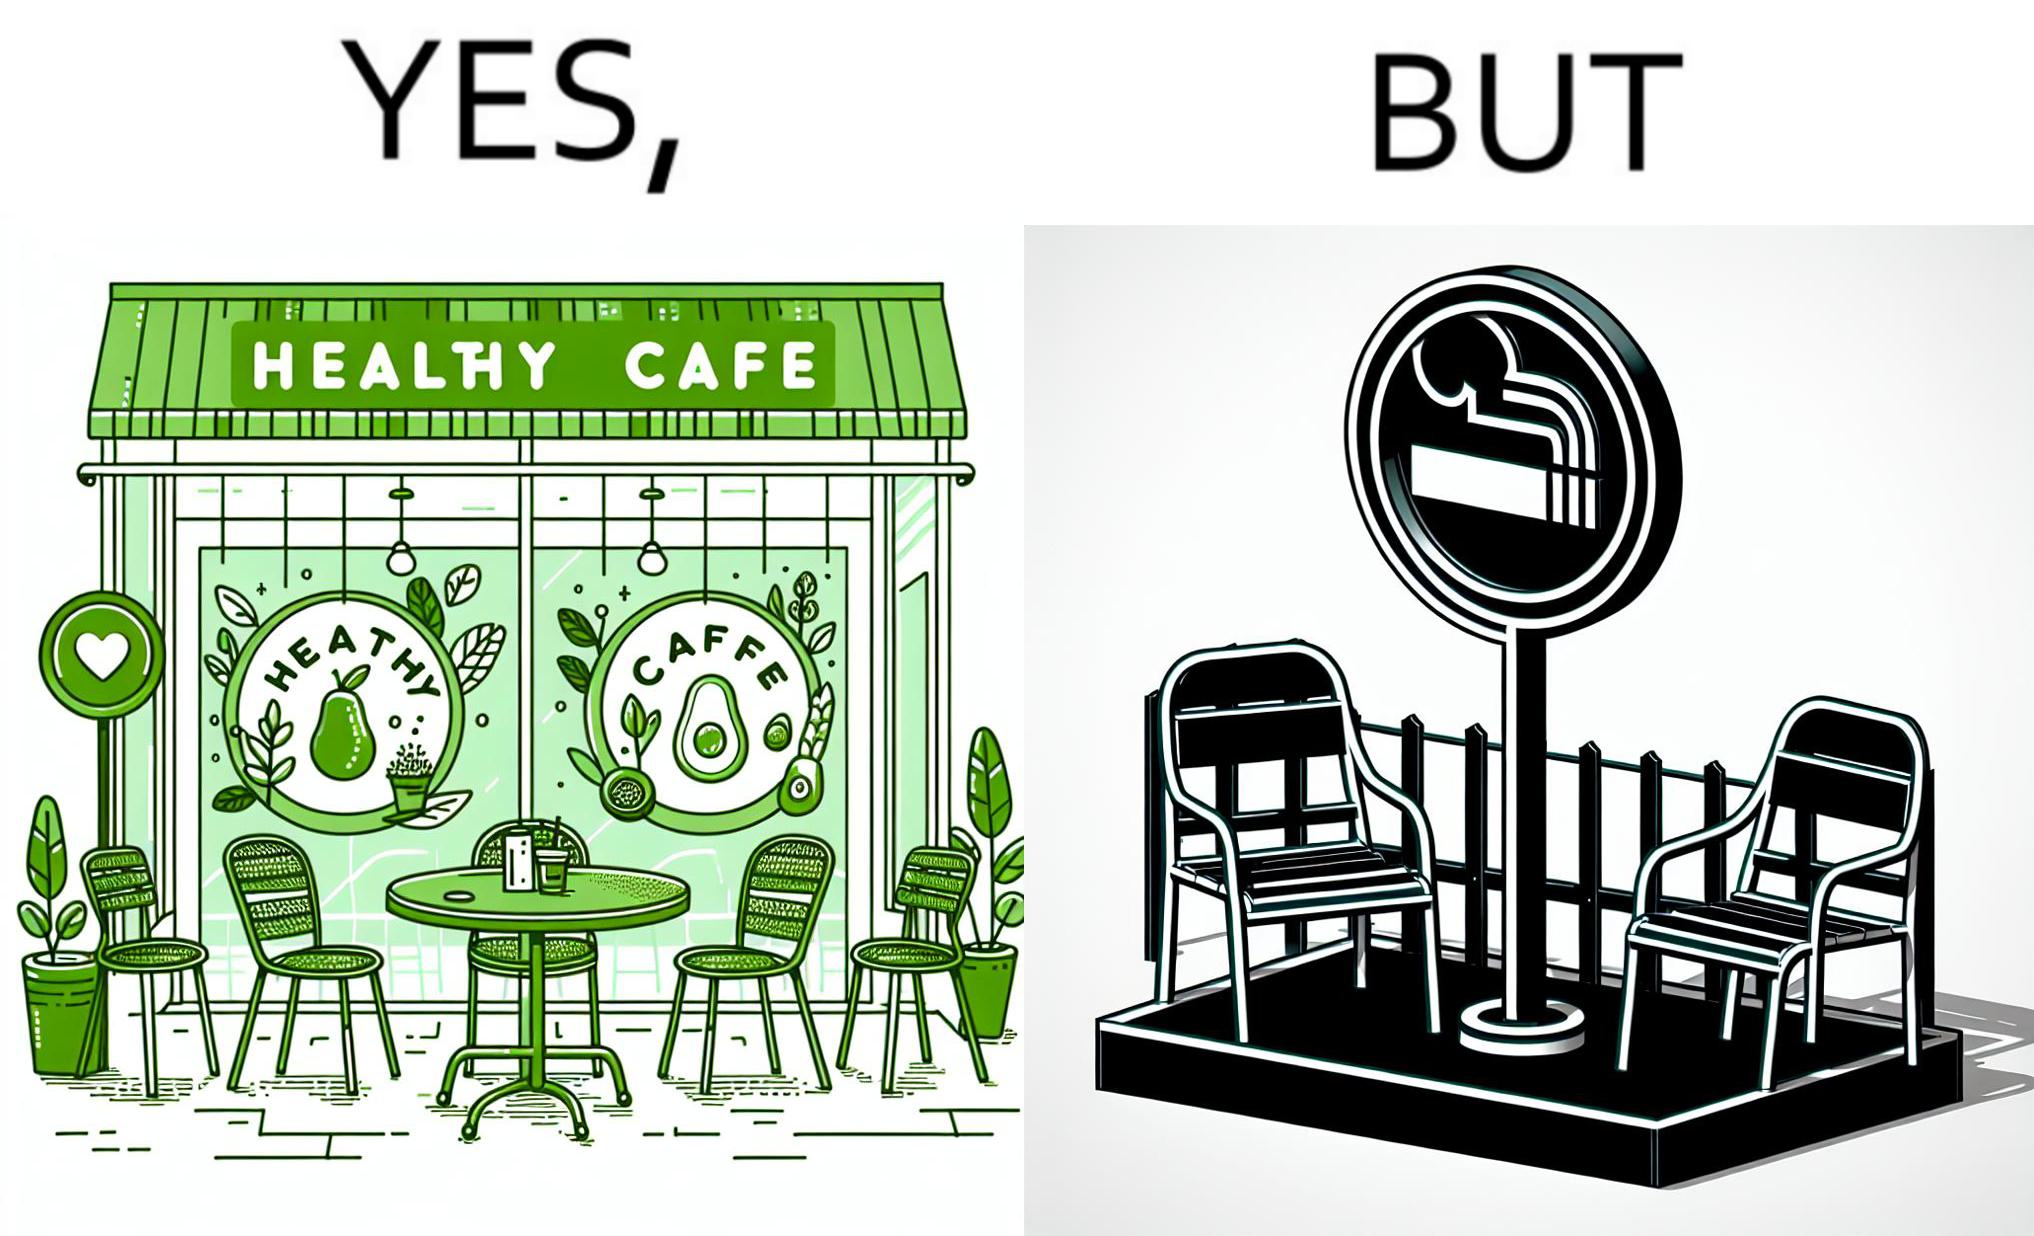What do you see in each half of this image? In the left part of the image: An eatery with the name "Healthy Cafe". It has a green aesthetic with paintings of leaves, avocados, etc on their windows. They have an outdoor seating area with 4 green patio chairs around a circular table. There is a small sign on a stand near the table with a green circular symbol and some text that is too small to read. In the right part of the image: Green patio chairs. A sign on a stand that has a green circular symbol encircling a cigarette symbol, and some text that says "SMOKING AREA". 